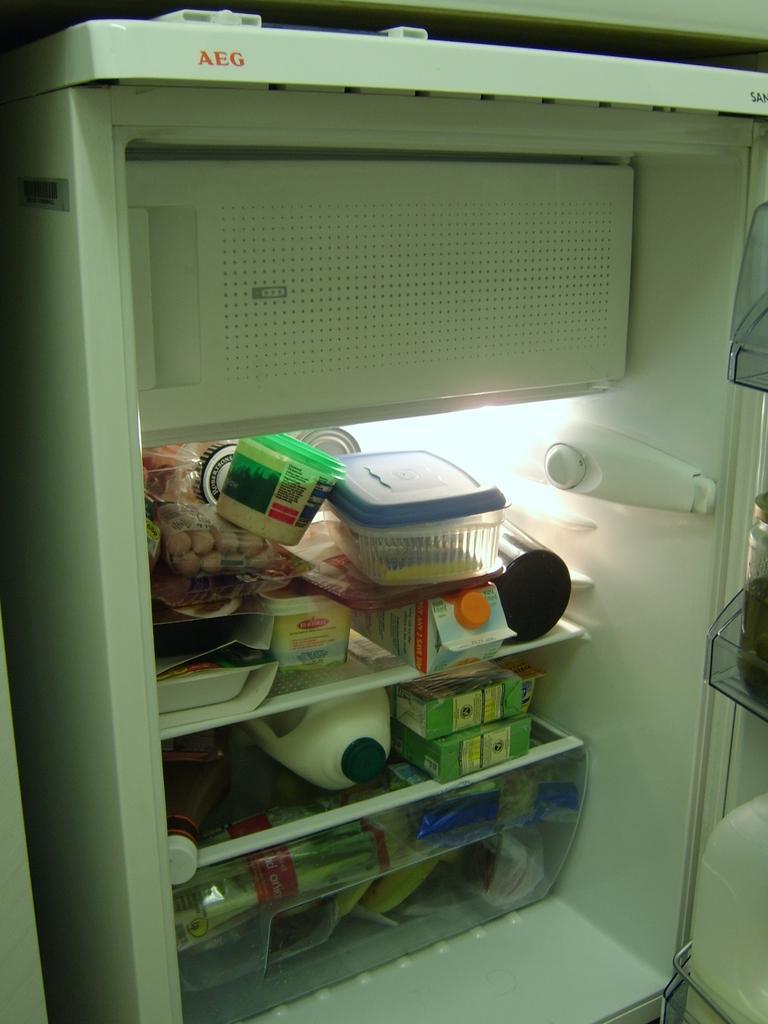How would you summarize this image in a sentence or two? In this image there is a milk can and some other food items in a refrigerator. 